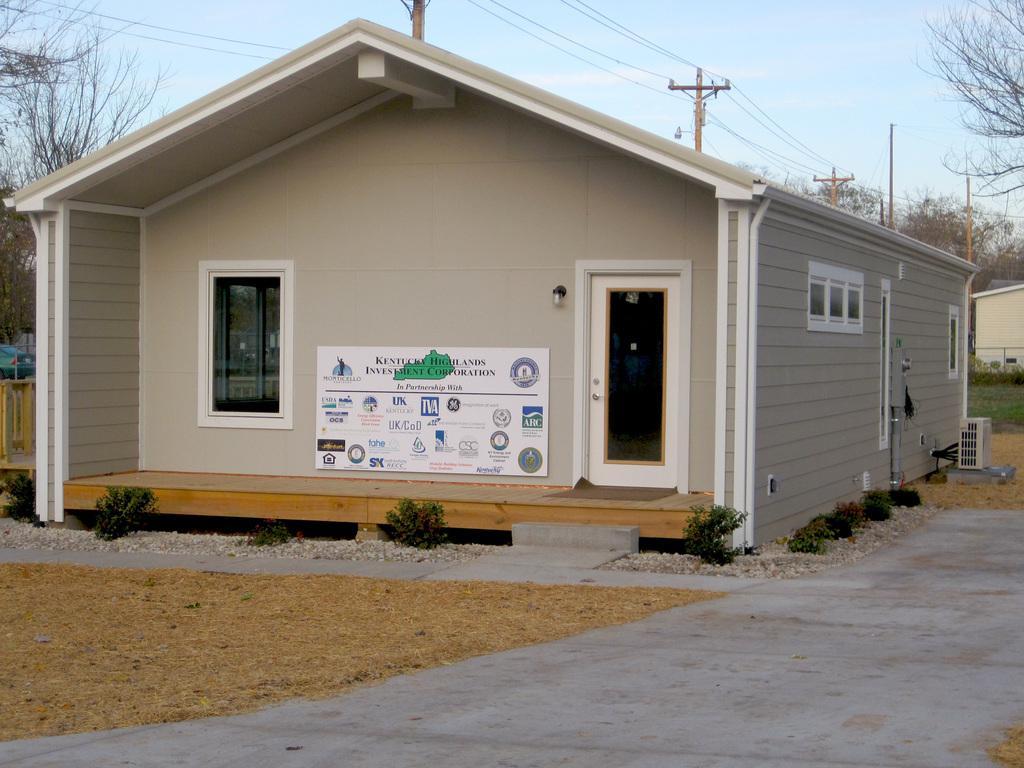Please provide a concise description of this image. In this there is a house, there is a window, there is a door, there is a board on which text is written, there is a light, there are plantś, there is tree towards the left of the image, there are poleś, there is streetlight, there are wires, there is a tree towards the right of the image, there is grass, there is a sky. 